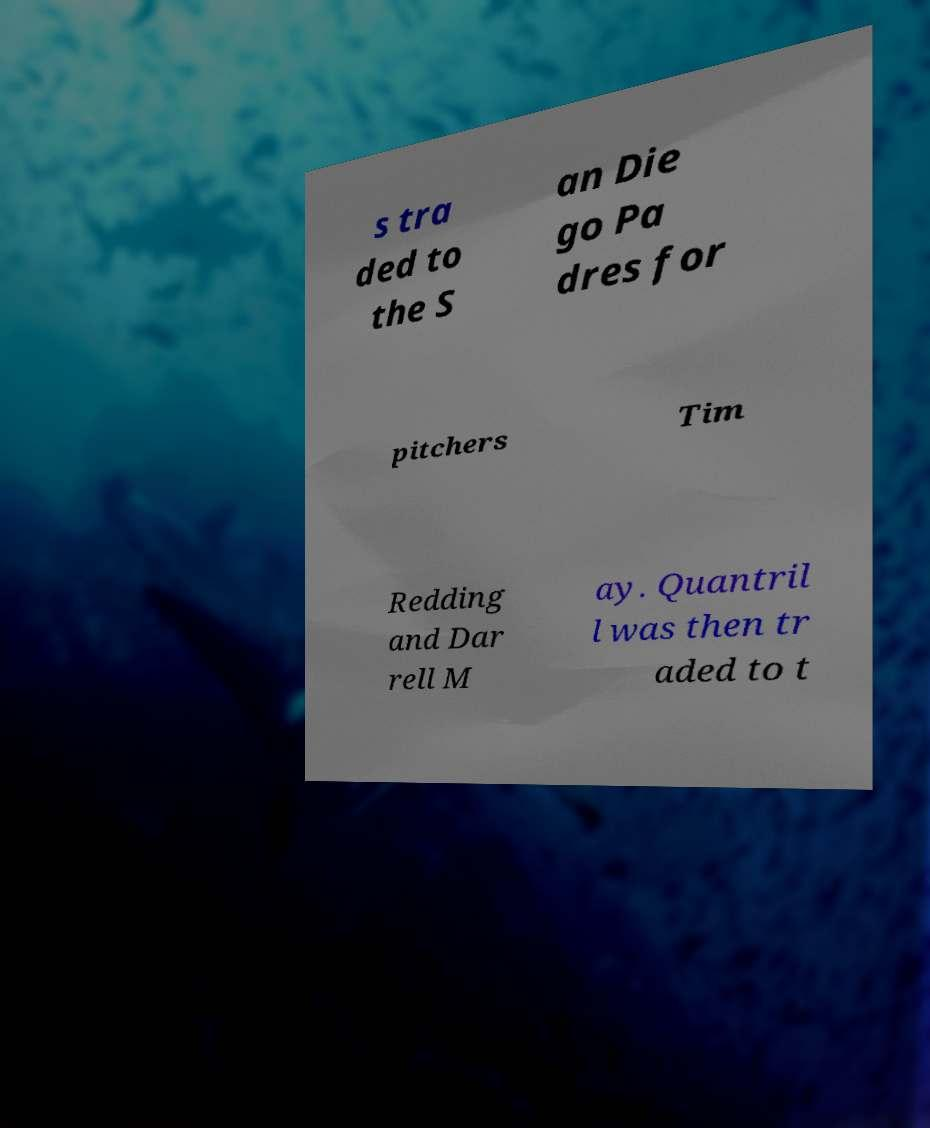Can you read and provide the text displayed in the image?This photo seems to have some interesting text. Can you extract and type it out for me? s tra ded to the S an Die go Pa dres for pitchers Tim Redding and Dar rell M ay. Quantril l was then tr aded to t 